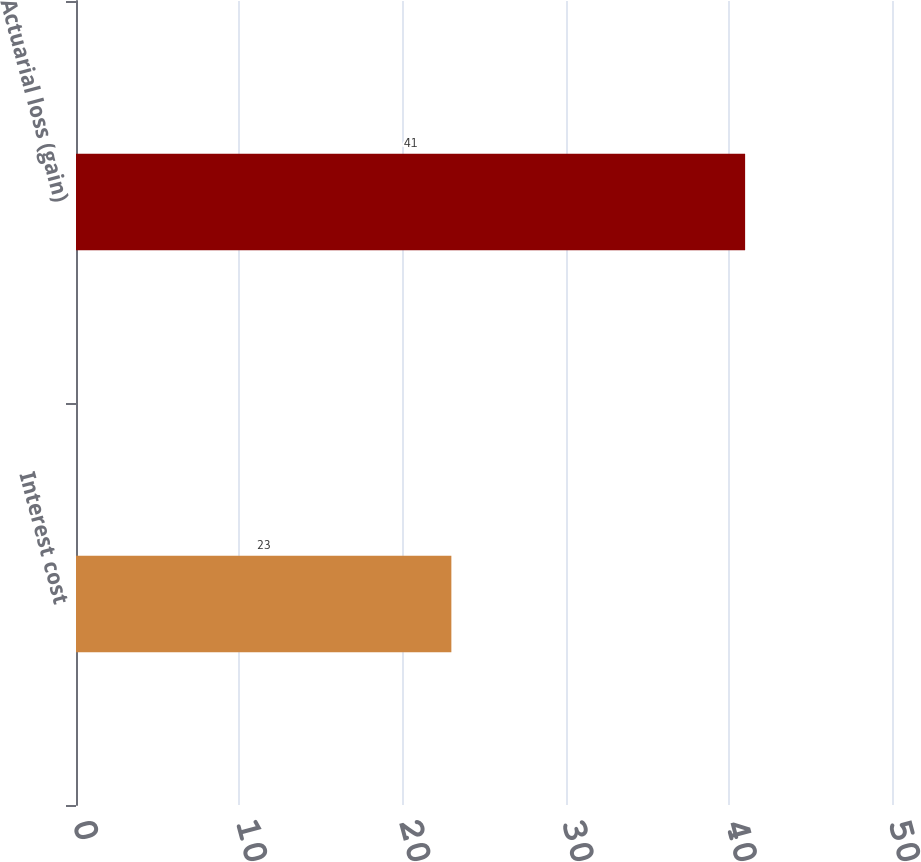Convert chart to OTSL. <chart><loc_0><loc_0><loc_500><loc_500><bar_chart><fcel>Interest cost<fcel>Actuarial loss (gain)<nl><fcel>23<fcel>41<nl></chart> 